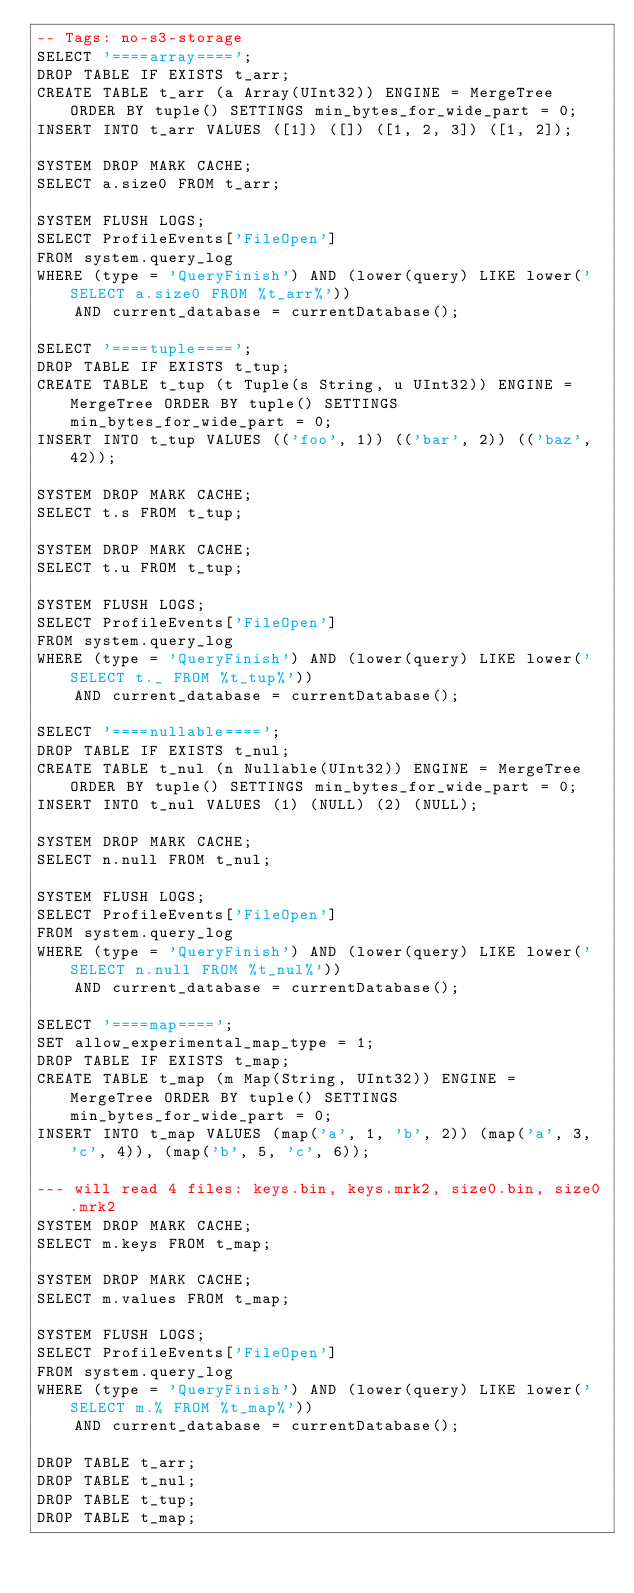Convert code to text. <code><loc_0><loc_0><loc_500><loc_500><_SQL_>-- Tags: no-s3-storage
SELECT '====array====';
DROP TABLE IF EXISTS t_arr;
CREATE TABLE t_arr (a Array(UInt32)) ENGINE = MergeTree ORDER BY tuple() SETTINGS min_bytes_for_wide_part = 0;
INSERT INTO t_arr VALUES ([1]) ([]) ([1, 2, 3]) ([1, 2]);

SYSTEM DROP MARK CACHE;
SELECT a.size0 FROM t_arr;

SYSTEM FLUSH LOGS;
SELECT ProfileEvents['FileOpen']
FROM system.query_log
WHERE (type = 'QueryFinish') AND (lower(query) LIKE lower('SELECT a.size0 FROM %t_arr%'))
    AND current_database = currentDatabase();

SELECT '====tuple====';
DROP TABLE IF EXISTS t_tup;
CREATE TABLE t_tup (t Tuple(s String, u UInt32)) ENGINE = MergeTree ORDER BY tuple() SETTINGS min_bytes_for_wide_part = 0;
INSERT INTO t_tup VALUES (('foo', 1)) (('bar', 2)) (('baz', 42));

SYSTEM DROP MARK CACHE;
SELECT t.s FROM t_tup;

SYSTEM DROP MARK CACHE;
SELECT t.u FROM t_tup;

SYSTEM FLUSH LOGS;
SELECT ProfileEvents['FileOpen']
FROM system.query_log
WHERE (type = 'QueryFinish') AND (lower(query) LIKE lower('SELECT t._ FROM %t_tup%'))
    AND current_database = currentDatabase();

SELECT '====nullable====';
DROP TABLE IF EXISTS t_nul;
CREATE TABLE t_nul (n Nullable(UInt32)) ENGINE = MergeTree ORDER BY tuple() SETTINGS min_bytes_for_wide_part = 0;
INSERT INTO t_nul VALUES (1) (NULL) (2) (NULL);

SYSTEM DROP MARK CACHE;
SELECT n.null FROM t_nul;

SYSTEM FLUSH LOGS;
SELECT ProfileEvents['FileOpen']
FROM system.query_log
WHERE (type = 'QueryFinish') AND (lower(query) LIKE lower('SELECT n.null FROM %t_nul%'))
    AND current_database = currentDatabase();

SELECT '====map====';
SET allow_experimental_map_type = 1;
DROP TABLE IF EXISTS t_map;
CREATE TABLE t_map (m Map(String, UInt32)) ENGINE = MergeTree ORDER BY tuple() SETTINGS min_bytes_for_wide_part = 0;
INSERT INTO t_map VALUES (map('a', 1, 'b', 2)) (map('a', 3, 'c', 4)), (map('b', 5, 'c', 6));

--- will read 4 files: keys.bin, keys.mrk2, size0.bin, size0.mrk2
SYSTEM DROP MARK CACHE;
SELECT m.keys FROM t_map;

SYSTEM DROP MARK CACHE;
SELECT m.values FROM t_map;

SYSTEM FLUSH LOGS;
SELECT ProfileEvents['FileOpen']
FROM system.query_log
WHERE (type = 'QueryFinish') AND (lower(query) LIKE lower('SELECT m.% FROM %t_map%'))
    AND current_database = currentDatabase();

DROP TABLE t_arr;
DROP TABLE t_nul;
DROP TABLE t_tup;
DROP TABLE t_map;
</code> 